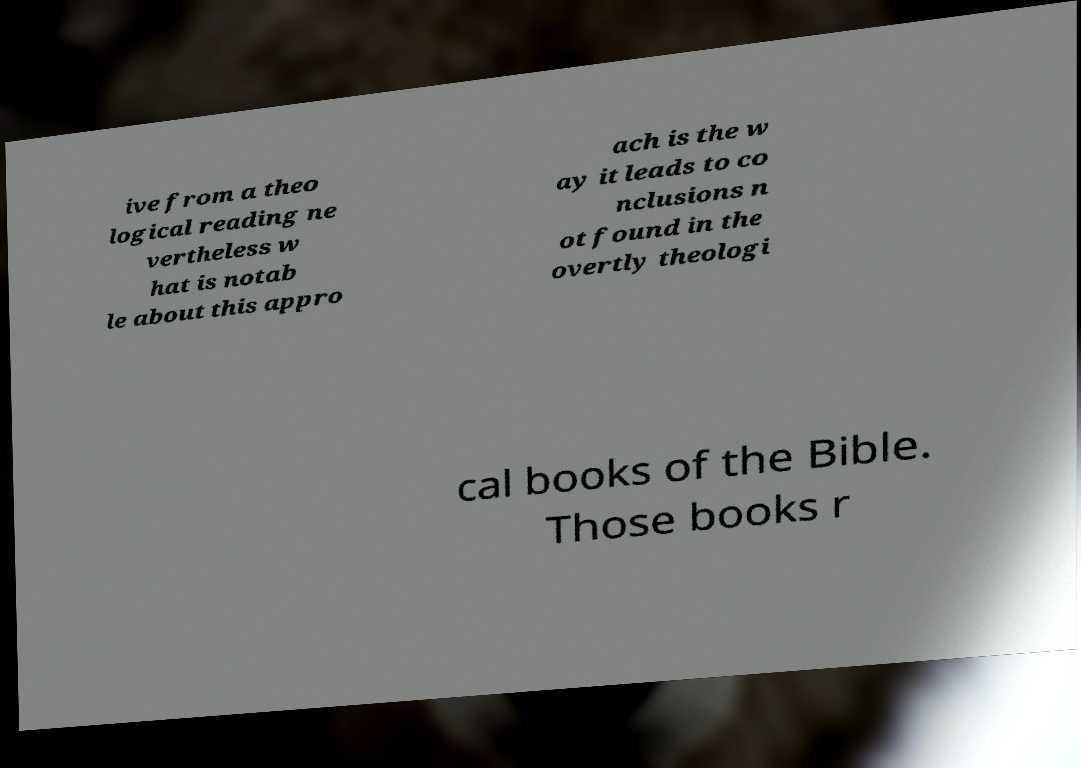Please read and relay the text visible in this image. What does it say? ive from a theo logical reading ne vertheless w hat is notab le about this appro ach is the w ay it leads to co nclusions n ot found in the overtly theologi cal books of the Bible. Those books r 